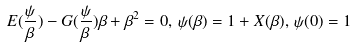<formula> <loc_0><loc_0><loc_500><loc_500>E ( \frac { \psi } { \beta } ) - G ( \frac { \psi } { \beta } ) \beta + \beta ^ { 2 } = 0 , \, \psi ( \beta ) = 1 + X ( \beta ) , \, \psi ( 0 ) = 1</formula> 